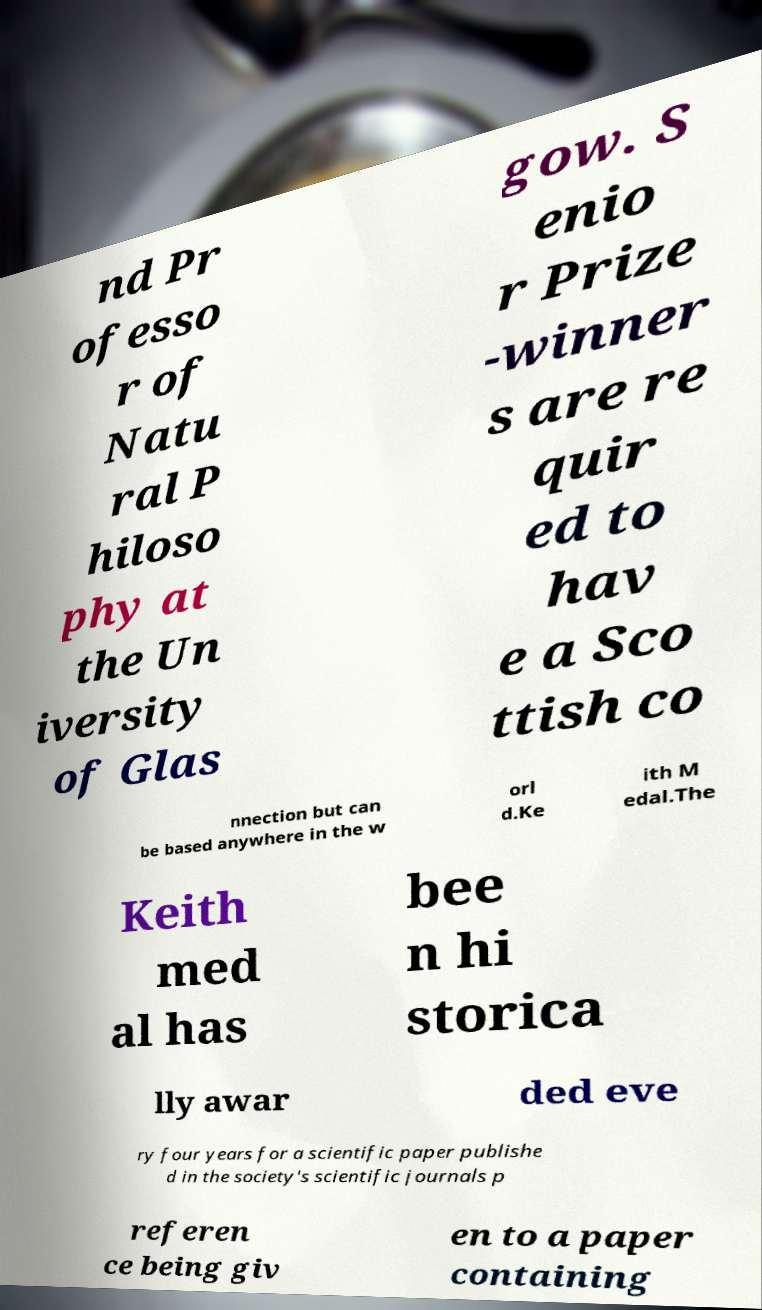There's text embedded in this image that I need extracted. Can you transcribe it verbatim? nd Pr ofesso r of Natu ral P hiloso phy at the Un iversity of Glas gow. S enio r Prize -winner s are re quir ed to hav e a Sco ttish co nnection but can be based anywhere in the w orl d.Ke ith M edal.The Keith med al has bee n hi storica lly awar ded eve ry four years for a scientific paper publishe d in the society's scientific journals p referen ce being giv en to a paper containing 